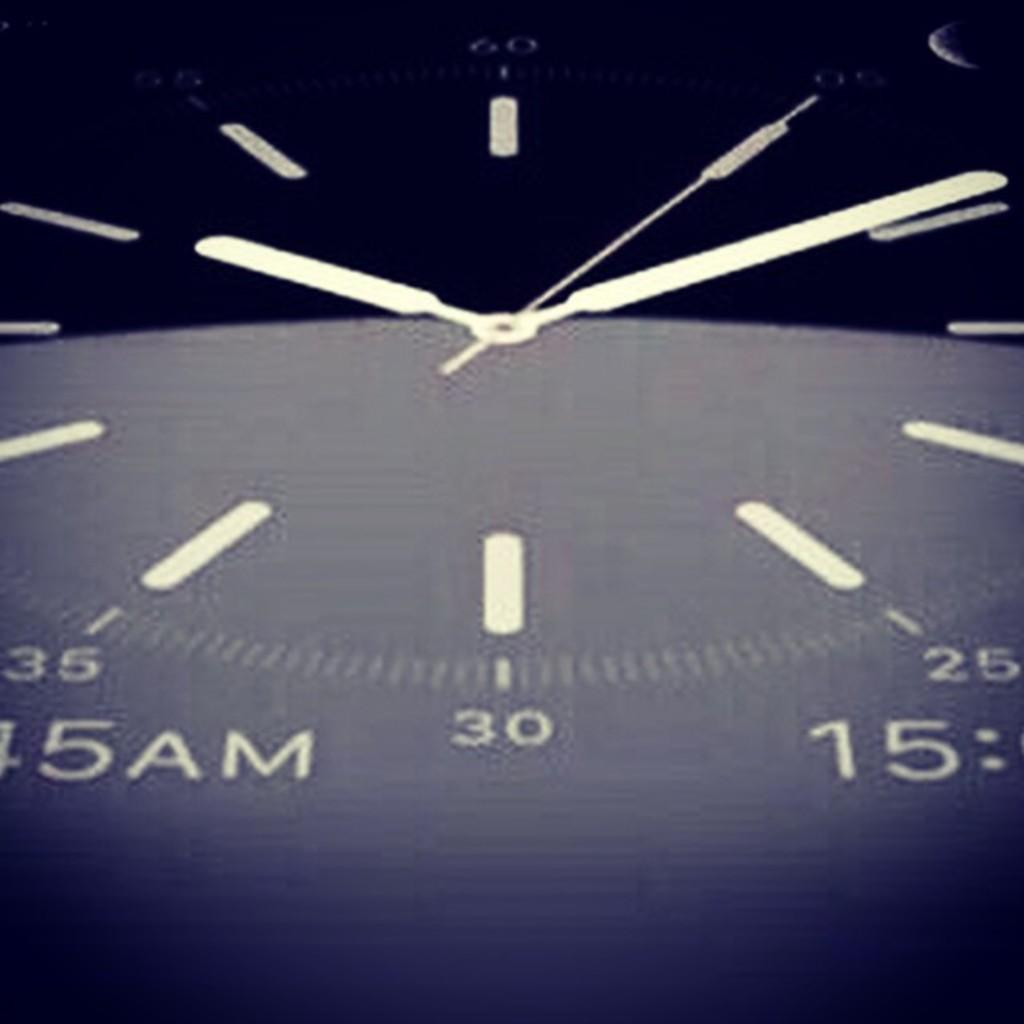<image>
Create a compact narrative representing the image presented. A close up of a clock shows the time to be 10:09 and some numbers that can be seen are 25, 30, 34 